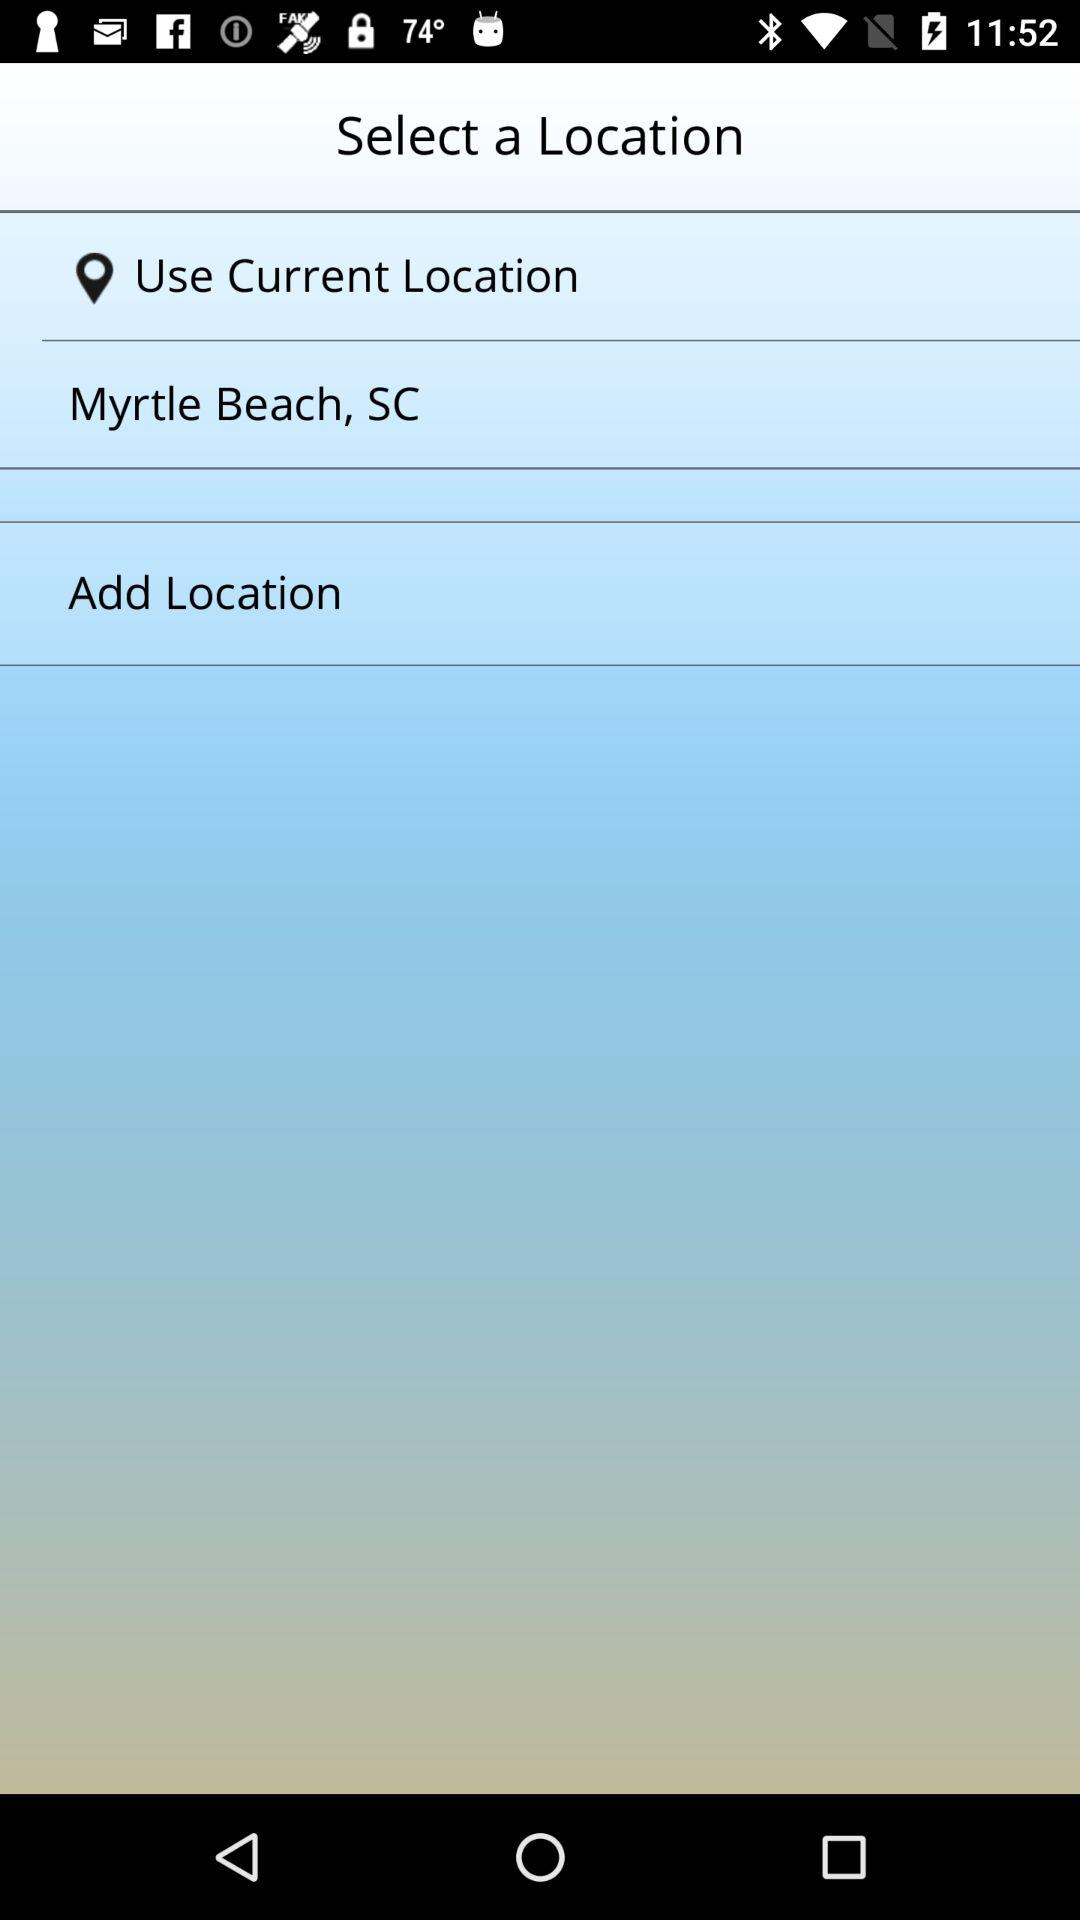How many locations are available to select from?
Answer the question using a single word or phrase. 2 